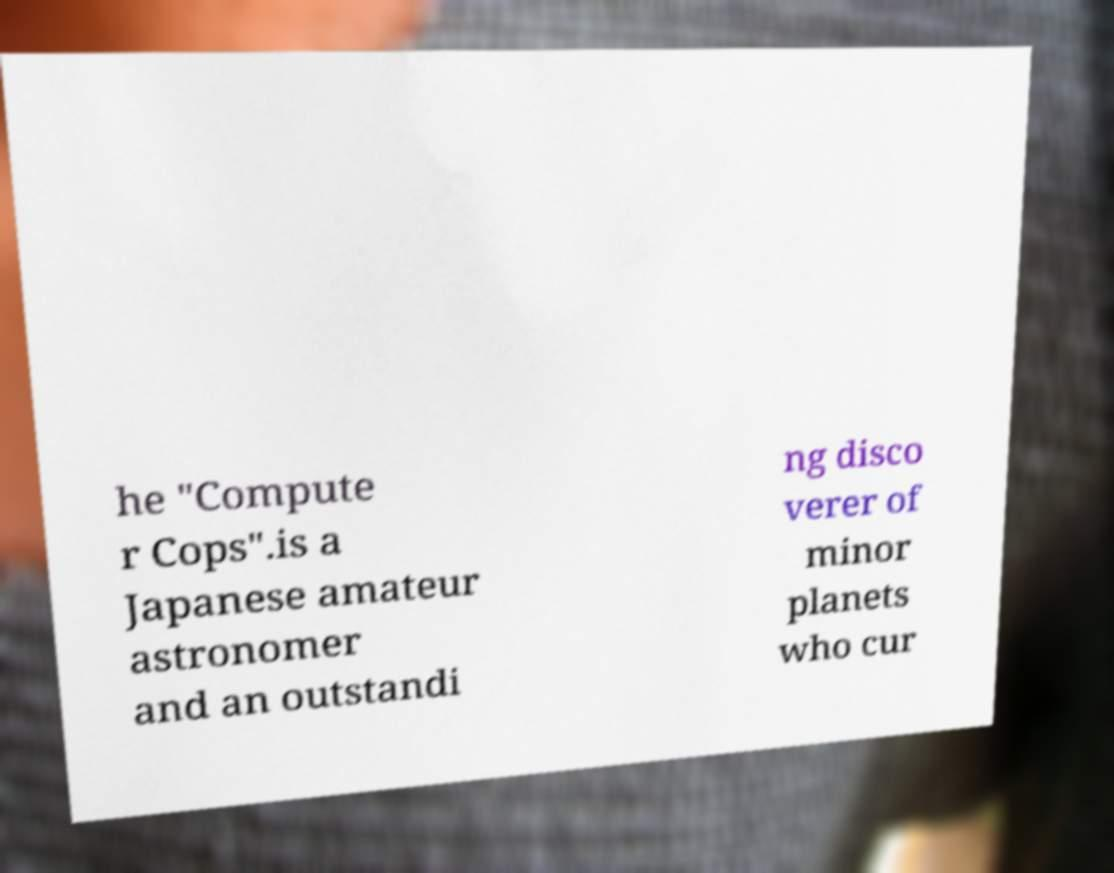Please identify and transcribe the text found in this image. he "Compute r Cops".is a Japanese amateur astronomer and an outstandi ng disco verer of minor planets who cur 